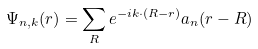Convert formula to latex. <formula><loc_0><loc_0><loc_500><loc_500>\Psi _ { n , k } ( r ) = \sum _ { R } e ^ { - i k \cdot ( R - r ) } a _ { n } ( r - R )</formula> 